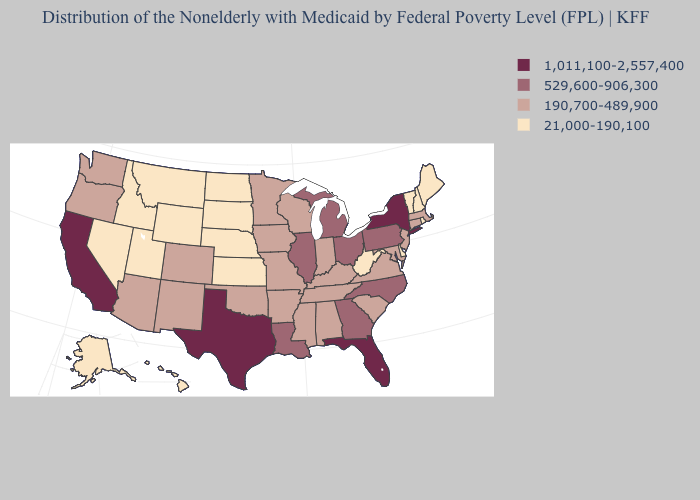Which states have the highest value in the USA?
Answer briefly. California, Florida, New York, Texas. Does Texas have the highest value in the USA?
Give a very brief answer. Yes. Among the states that border Louisiana , which have the lowest value?
Quick response, please. Arkansas, Mississippi. Name the states that have a value in the range 190,700-489,900?
Write a very short answer. Alabama, Arizona, Arkansas, Colorado, Connecticut, Indiana, Iowa, Kentucky, Maryland, Massachusetts, Minnesota, Mississippi, Missouri, New Jersey, New Mexico, Oklahoma, Oregon, South Carolina, Tennessee, Virginia, Washington, Wisconsin. Does Nevada have the lowest value in the USA?
Concise answer only. Yes. What is the highest value in the South ?
Be succinct. 1,011,100-2,557,400. Name the states that have a value in the range 21,000-190,100?
Answer briefly. Alaska, Delaware, Hawaii, Idaho, Kansas, Maine, Montana, Nebraska, Nevada, New Hampshire, North Dakota, Rhode Island, South Dakota, Utah, Vermont, West Virginia, Wyoming. Does Massachusetts have the lowest value in the Northeast?
Write a very short answer. No. Which states have the lowest value in the Northeast?
Quick response, please. Maine, New Hampshire, Rhode Island, Vermont. Does California have the highest value in the USA?
Keep it brief. Yes. Name the states that have a value in the range 529,600-906,300?
Quick response, please. Georgia, Illinois, Louisiana, Michigan, North Carolina, Ohio, Pennsylvania. Does the first symbol in the legend represent the smallest category?
Be succinct. No. Which states have the lowest value in the Northeast?
Short answer required. Maine, New Hampshire, Rhode Island, Vermont. Among the states that border Kansas , which have the highest value?
Concise answer only. Colorado, Missouri, Oklahoma. Name the states that have a value in the range 1,011,100-2,557,400?
Give a very brief answer. California, Florida, New York, Texas. 